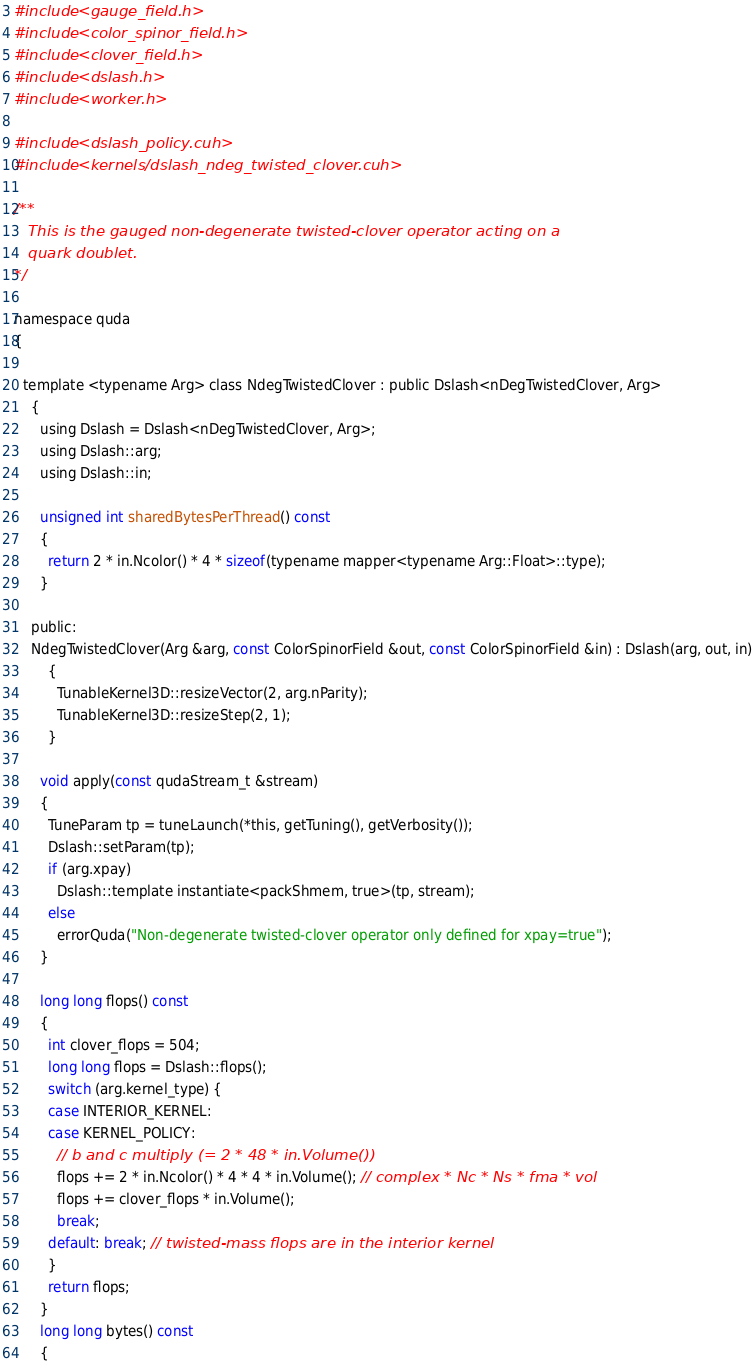<code> <loc_0><loc_0><loc_500><loc_500><_Cuda_>#include <gauge_field.h>
#include <color_spinor_field.h>
#include <clover_field.h>
#include <dslash.h>
#include <worker.h>

#include <dslash_policy.cuh>
#include <kernels/dslash_ndeg_twisted_clover.cuh>

/**
   This is the gauged non-degenerate twisted-clover operator acting on a 
   quark doublet.
*/

namespace quda
{

  template <typename Arg> class NdegTwistedClover : public Dslash<nDegTwistedClover, Arg>
    {
      using Dslash = Dslash<nDegTwistedClover, Arg>;
      using Dslash::arg;
      using Dslash::in;

      unsigned int sharedBytesPerThread() const
      {
        return 2 * in.Ncolor() * 4 * sizeof(typename mapper<typename Arg::Float>::type);
      }

    public:
    NdegTwistedClover(Arg &arg, const ColorSpinorField &out, const ColorSpinorField &in) : Dslash(arg, out, in)
        {
          TunableKernel3D::resizeVector(2, arg.nParity);
          TunableKernel3D::resizeStep(2, 1);
        }
      
      void apply(const qudaStream_t &stream)
      {
        TuneParam tp = tuneLaunch(*this, getTuning(), getVerbosity());
        Dslash::setParam(tp);
        if (arg.xpay)
          Dslash::template instantiate<packShmem, true>(tp, stream);
        else
          errorQuda("Non-degenerate twisted-clover operator only defined for xpay=true");
      }
      
      long long flops() const
      {
        int clover_flops = 504;
        long long flops = Dslash::flops();
        switch (arg.kernel_type) {
        case INTERIOR_KERNEL:
        case KERNEL_POLICY:
          // b and c multiply (= 2 * 48 * in.Volume())
          flops += 2 * in.Ncolor() * 4 * 4 * in.Volume(); // complex * Nc * Ns * fma * vol
          flops += clover_flops * in.Volume();
          break;
        default: break; // twisted-mass flops are in the interior kernel
        }
        return flops;
      }
      long long bytes() const
      {</code> 